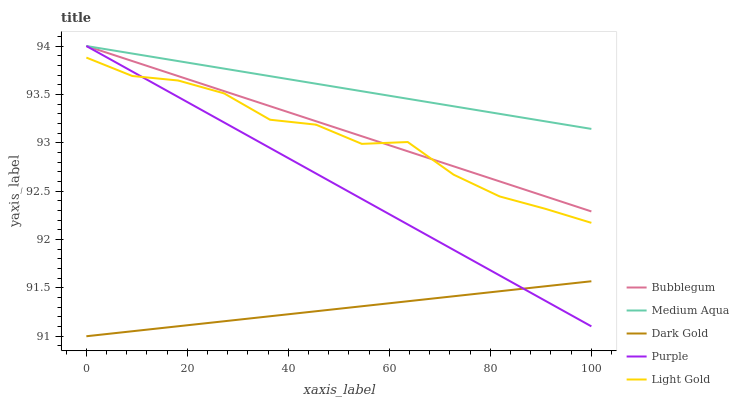Does Dark Gold have the minimum area under the curve?
Answer yes or no. Yes. Does Medium Aqua have the maximum area under the curve?
Answer yes or no. Yes. Does Light Gold have the minimum area under the curve?
Answer yes or no. No. Does Light Gold have the maximum area under the curve?
Answer yes or no. No. Is Dark Gold the smoothest?
Answer yes or no. Yes. Is Light Gold the roughest?
Answer yes or no. Yes. Is Medium Aqua the smoothest?
Answer yes or no. No. Is Medium Aqua the roughest?
Answer yes or no. No. Does Light Gold have the lowest value?
Answer yes or no. No. Does Light Gold have the highest value?
Answer yes or no. No. Is Dark Gold less than Medium Aqua?
Answer yes or no. Yes. Is Medium Aqua greater than Light Gold?
Answer yes or no. Yes. Does Dark Gold intersect Medium Aqua?
Answer yes or no. No. 